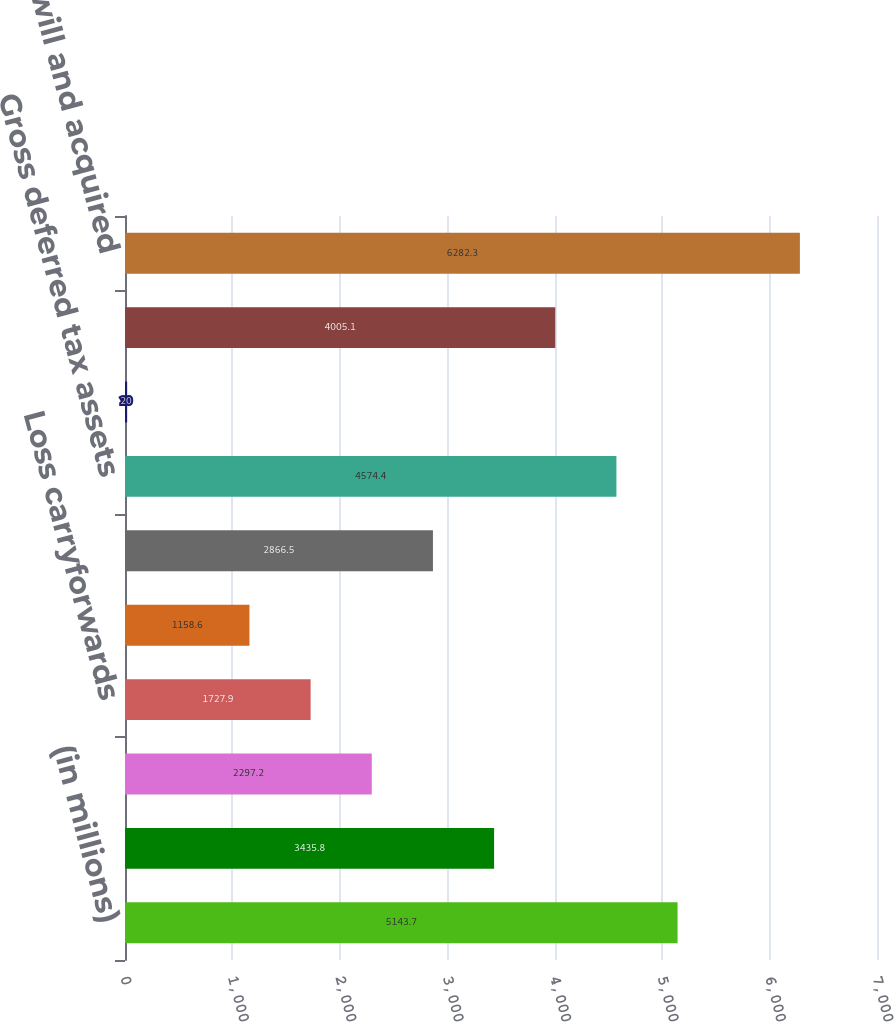<chart> <loc_0><loc_0><loc_500><loc_500><bar_chart><fcel>(in millions)<fcel>Compensation and benefits<fcel>Unrealized investment losses<fcel>Loss carryforwards<fcel>Foreign tax credit<fcel>Other<fcel>Gross deferred tax assets<fcel>Less deferred tax valuation<fcel>Deferred tax assets net of<fcel>Goodwill and acquired<nl><fcel>5143.7<fcel>3435.8<fcel>2297.2<fcel>1727.9<fcel>1158.6<fcel>2866.5<fcel>4574.4<fcel>20<fcel>4005.1<fcel>6282.3<nl></chart> 